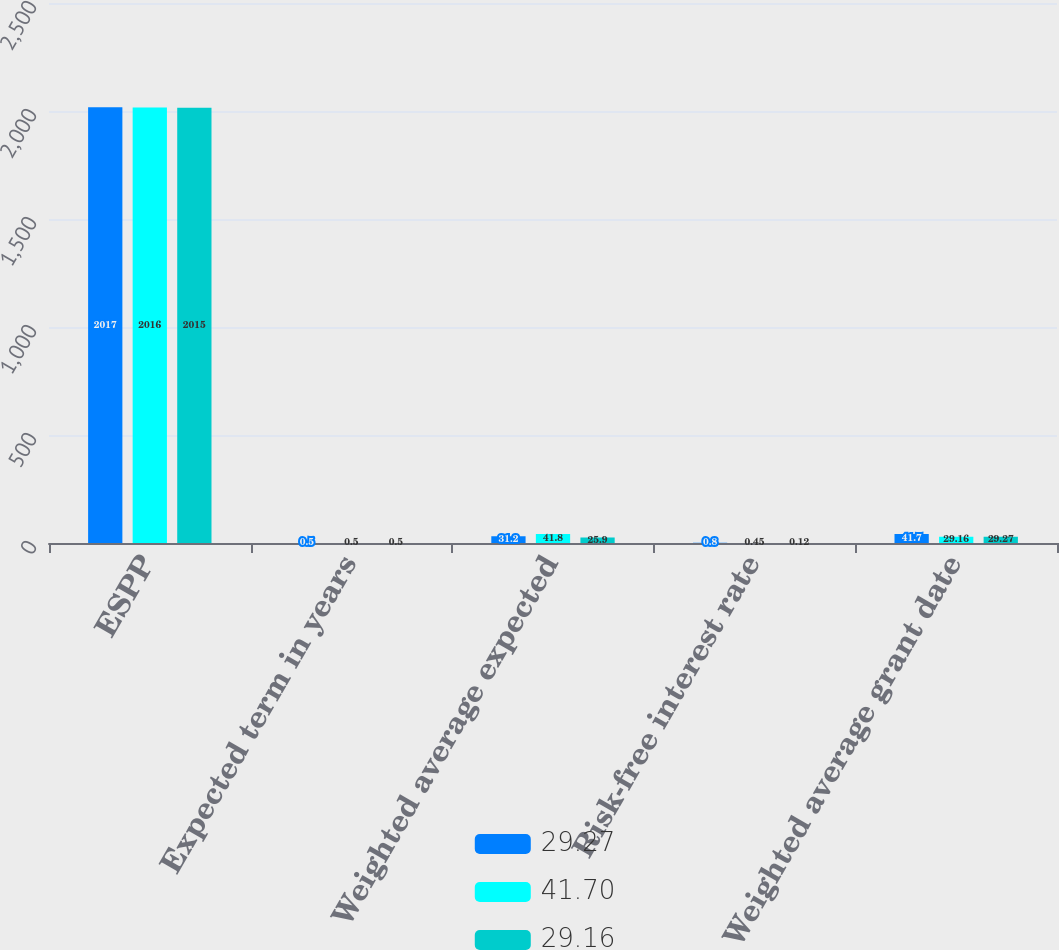Convert chart to OTSL. <chart><loc_0><loc_0><loc_500><loc_500><stacked_bar_chart><ecel><fcel>ESPP<fcel>Expected term in years<fcel>Weighted average expected<fcel>Risk-free interest rate<fcel>Weighted average grant date<nl><fcel>29.27<fcel>2017<fcel>0.5<fcel>31.2<fcel>0.8<fcel>41.7<nl><fcel>41.7<fcel>2016<fcel>0.5<fcel>41.8<fcel>0.45<fcel>29.16<nl><fcel>29.16<fcel>2015<fcel>0.5<fcel>25.9<fcel>0.12<fcel>29.27<nl></chart> 